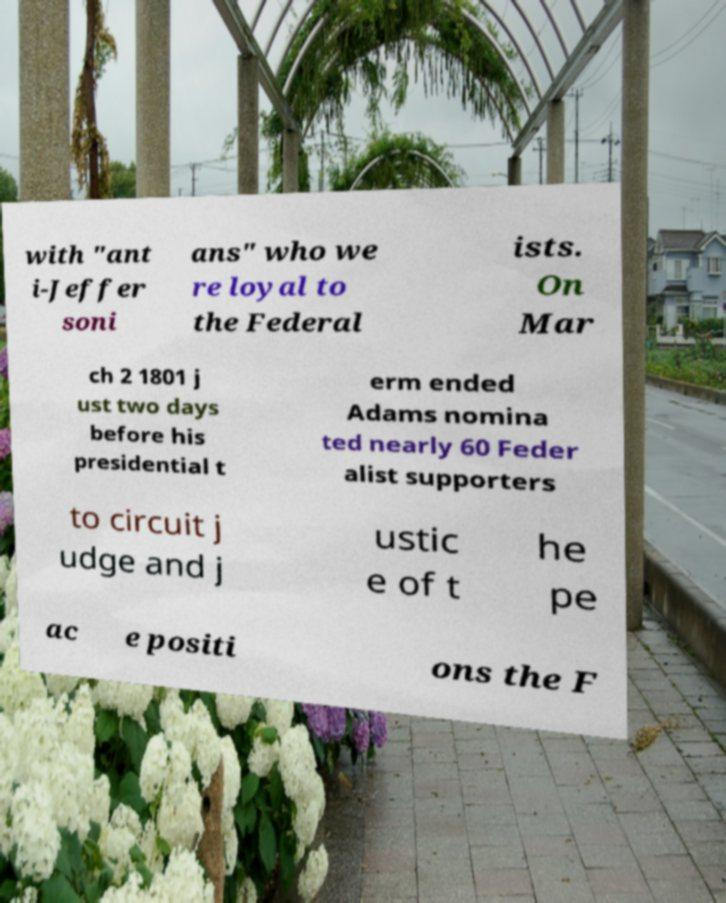Can you accurately transcribe the text from the provided image for me? with "ant i-Jeffer soni ans" who we re loyal to the Federal ists. On Mar ch 2 1801 j ust two days before his presidential t erm ended Adams nomina ted nearly 60 Feder alist supporters to circuit j udge and j ustic e of t he pe ac e positi ons the F 